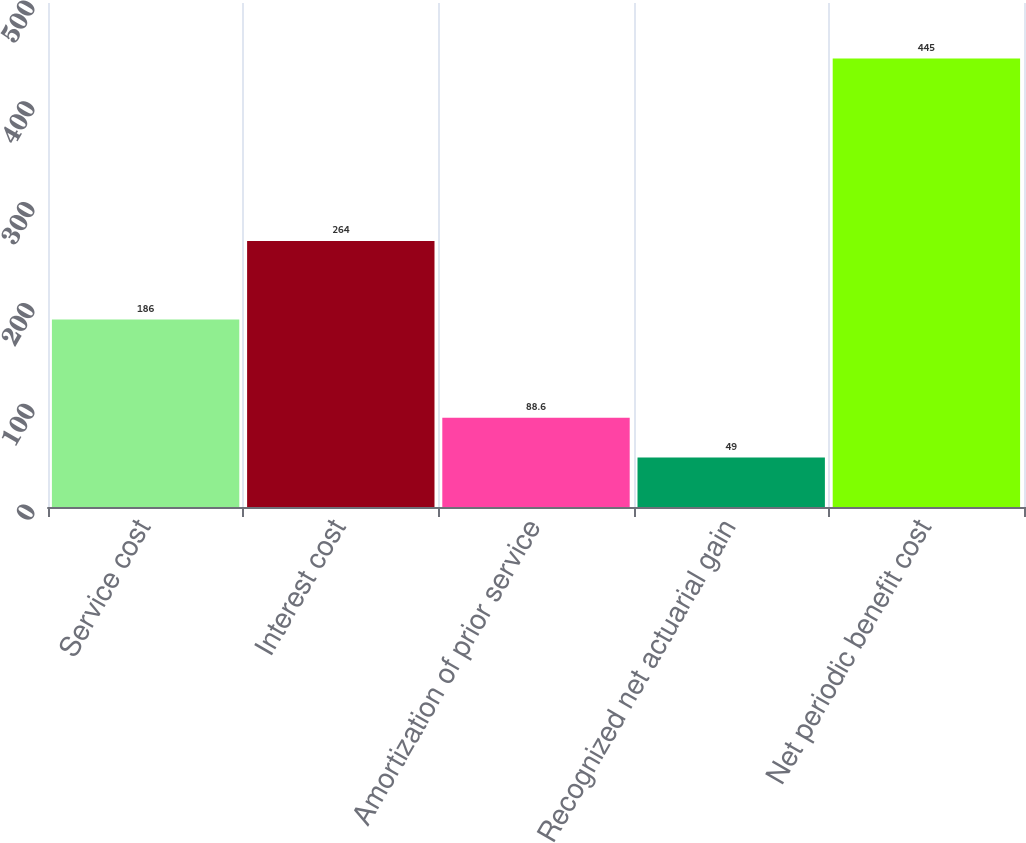<chart> <loc_0><loc_0><loc_500><loc_500><bar_chart><fcel>Service cost<fcel>Interest cost<fcel>Amortization of prior service<fcel>Recognized net actuarial gain<fcel>Net periodic benefit cost<nl><fcel>186<fcel>264<fcel>88.6<fcel>49<fcel>445<nl></chart> 